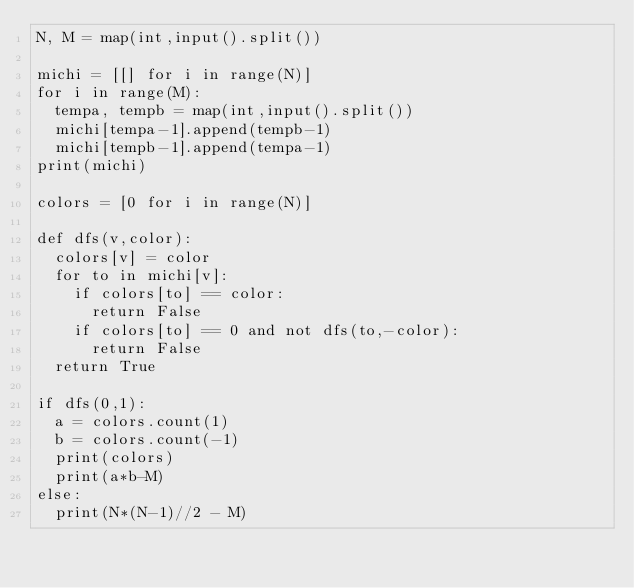<code> <loc_0><loc_0><loc_500><loc_500><_Python_>N, M = map(int,input().split())

michi = [[] for i in range(N)]
for i in range(M):
  tempa, tempb = map(int,input().split())
  michi[tempa-1].append(tempb-1)
  michi[tempb-1].append(tempa-1)
print(michi)
  
colors = [0 for i in range(N)]

def dfs(v,color):
  colors[v] = color
  for to in michi[v]:
    if colors[to] == color:
      return False
    if colors[to] == 0 and not dfs(to,-color):
      return False
  return True

if dfs(0,1):
  a = colors.count(1)
  b = colors.count(-1)
  print(colors)
  print(a*b-M)
else:
  print(N*(N-1)//2 - M)</code> 